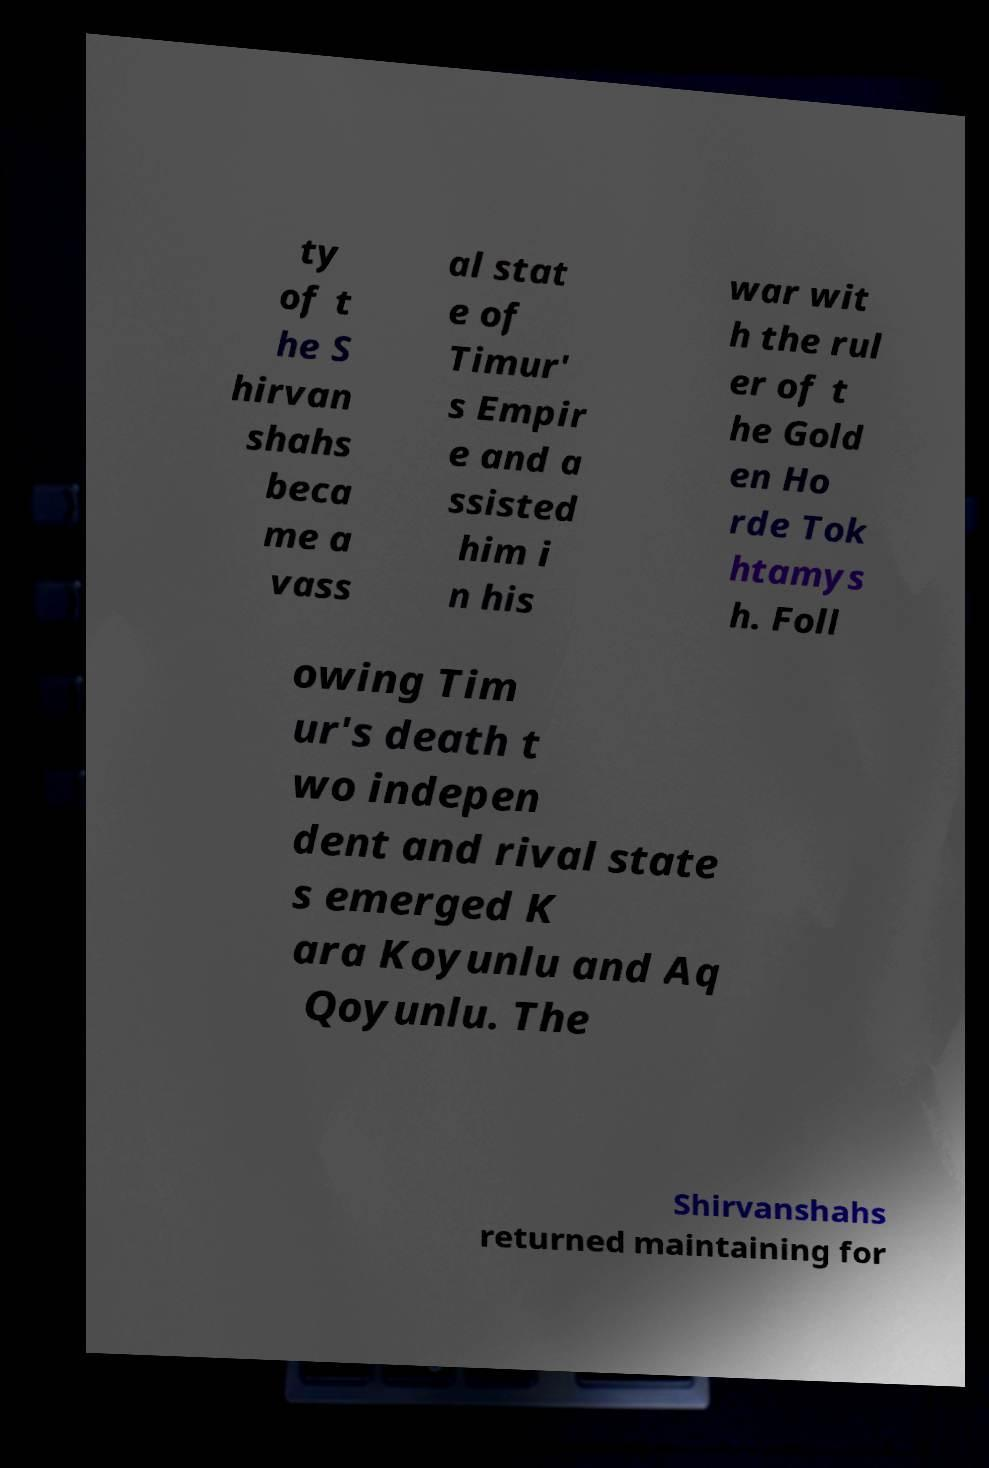Can you accurately transcribe the text from the provided image for me? ty of t he S hirvan shahs beca me a vass al stat e of Timur' s Empir e and a ssisted him i n his war wit h the rul er of t he Gold en Ho rde Tok htamys h. Foll owing Tim ur's death t wo indepen dent and rival state s emerged K ara Koyunlu and Aq Qoyunlu. The Shirvanshahs returned maintaining for 